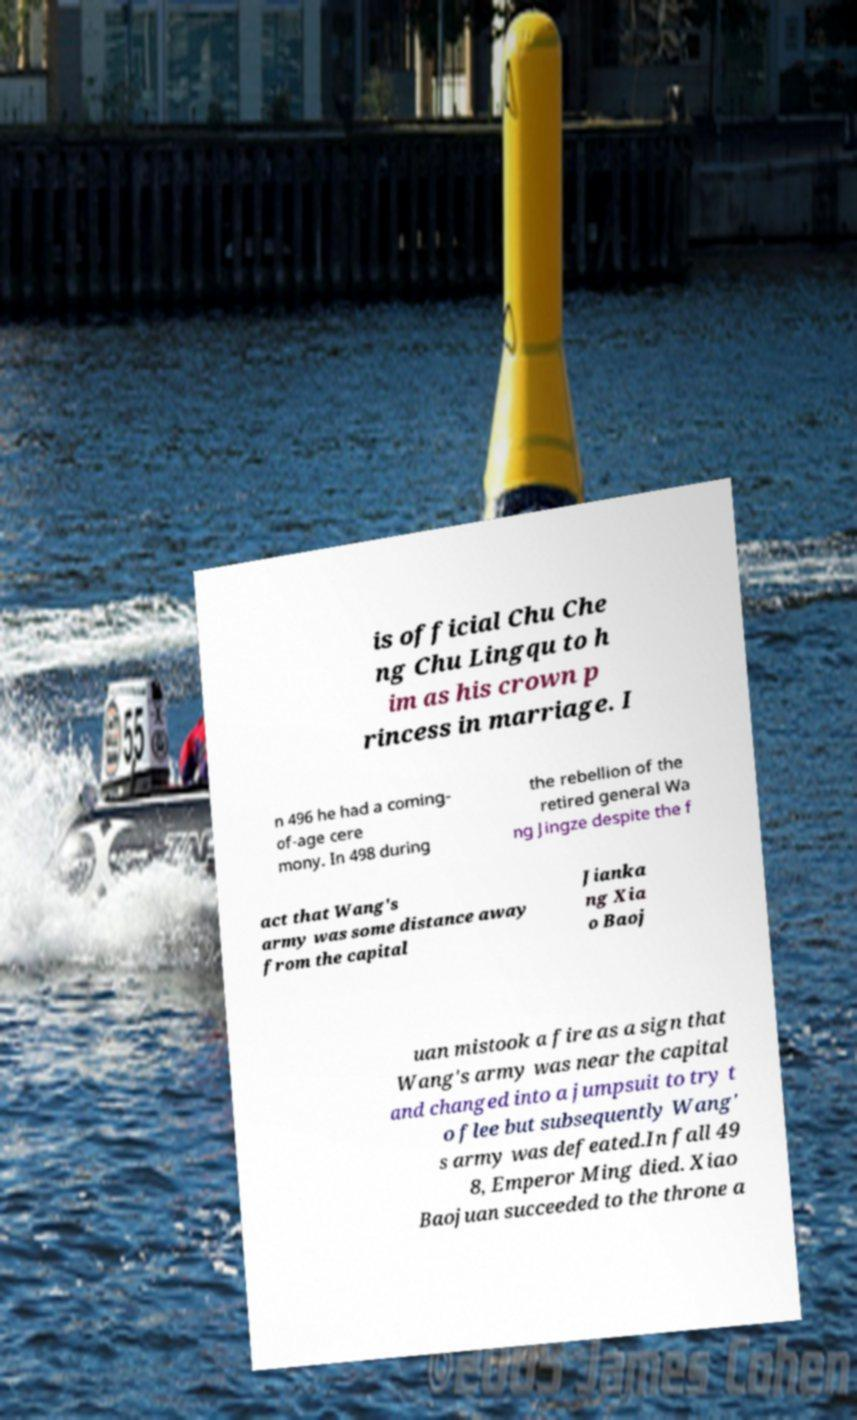I need the written content from this picture converted into text. Can you do that? is official Chu Che ng Chu Lingqu to h im as his crown p rincess in marriage. I n 496 he had a coming- of-age cere mony. In 498 during the rebellion of the retired general Wa ng Jingze despite the f act that Wang's army was some distance away from the capital Jianka ng Xia o Baoj uan mistook a fire as a sign that Wang's army was near the capital and changed into a jumpsuit to try t o flee but subsequently Wang' s army was defeated.In fall 49 8, Emperor Ming died. Xiao Baojuan succeeded to the throne a 